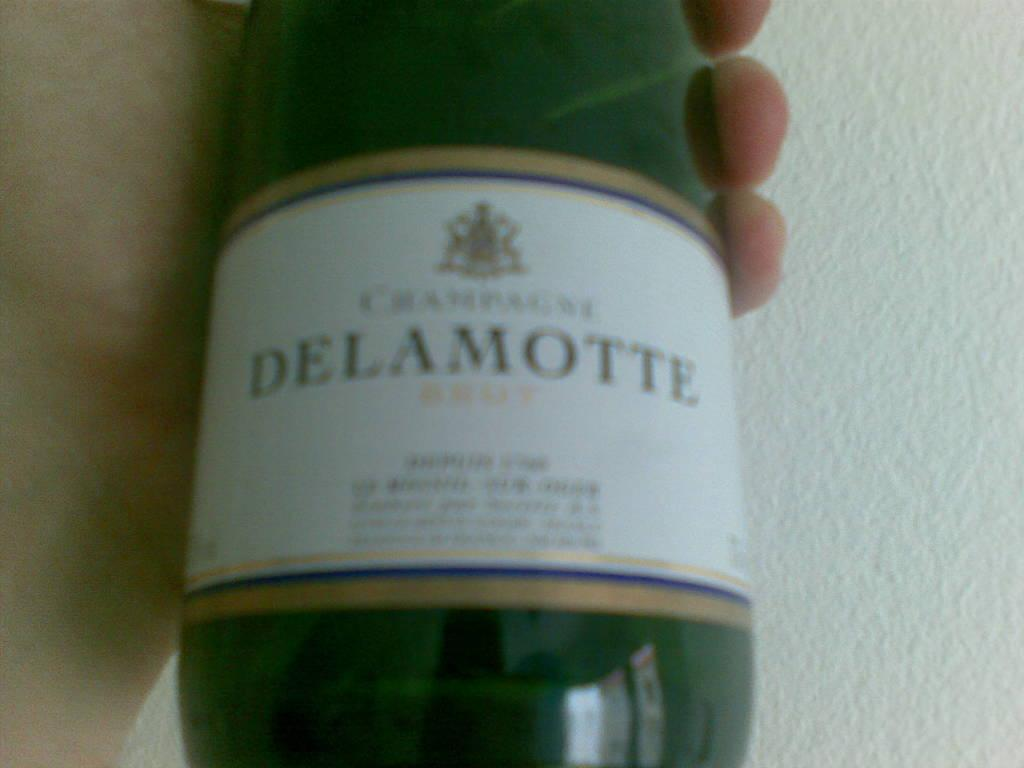Provide a one-sentence caption for the provided image. a green glass bottle of Delamotte held in a hand. 